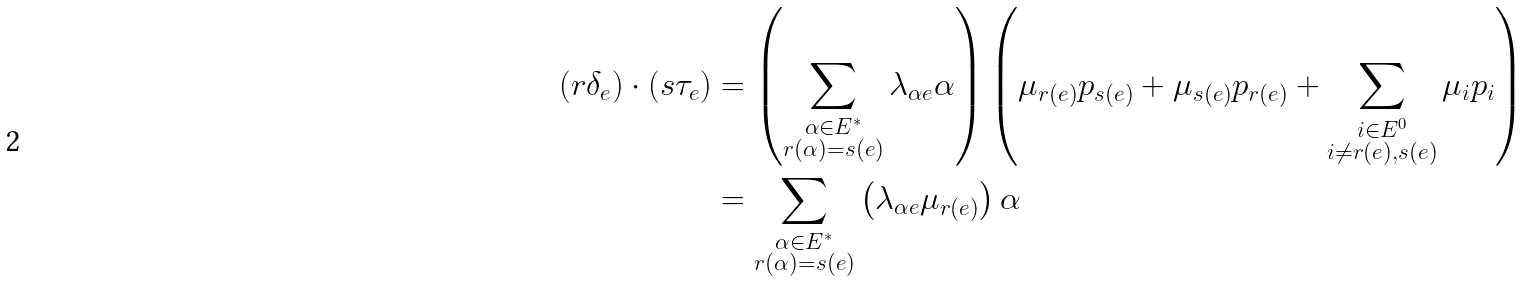<formula> <loc_0><loc_0><loc_500><loc_500>( r \delta _ { e } ) \cdot ( s \tau _ { e } ) & = \left ( \sum _ { \substack { \alpha \in E ^ { * } \\ r ( \alpha ) = s ( e ) } } \lambda _ { \alpha e } \alpha \right ) \left ( \mu _ { r ( e ) } p _ { s ( e ) } + \mu _ { s ( e ) } p _ { r ( e ) } + \sum _ { \substack { i \in E ^ { 0 } \\ i \neq r ( e ) , s ( e ) } } \mu _ { i } p _ { i } \right ) \\ & = \sum _ { \substack { \alpha \in E ^ { * } \\ r ( \alpha ) = s ( e ) } } \left ( \lambda _ { \alpha e } \mu _ { r ( e ) } \right ) \alpha</formula> 